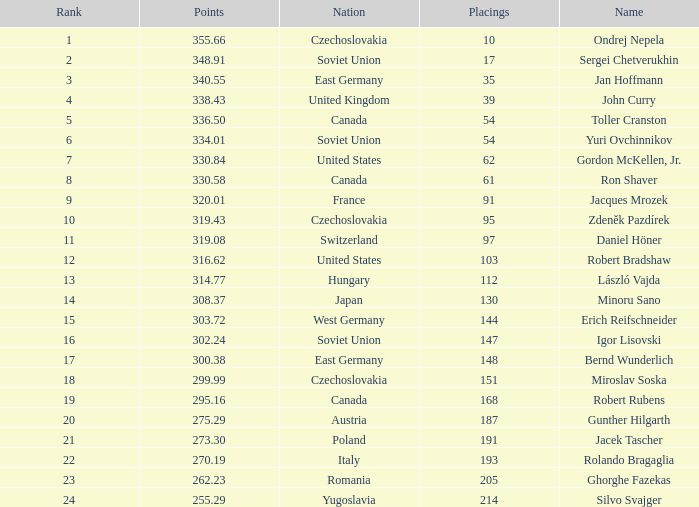Which Placings have a Nation of west germany, and Points larger than 303.72? None. 